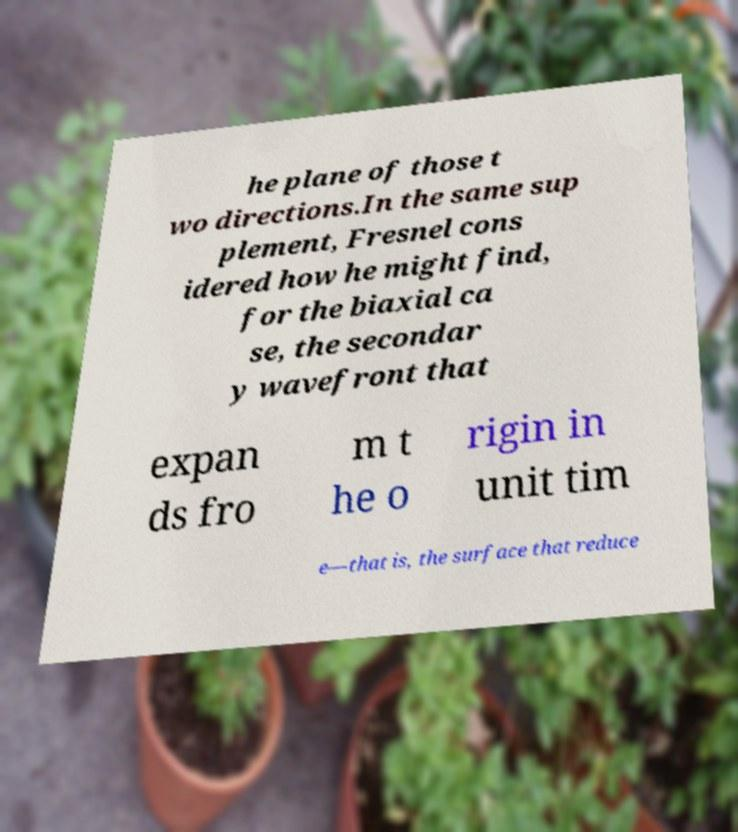What messages or text are displayed in this image? I need them in a readable, typed format. he plane of those t wo directions.In the same sup plement, Fresnel cons idered how he might find, for the biaxial ca se, the secondar y wavefront that expan ds fro m t he o rigin in unit tim e—that is, the surface that reduce 